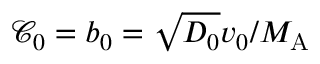<formula> <loc_0><loc_0><loc_500><loc_500>{ \mathcal { C } } _ { 0 } = b _ { 0 } = \sqrt { D _ { 0 } } v _ { 0 } / M _ { \mathrm A }</formula> 